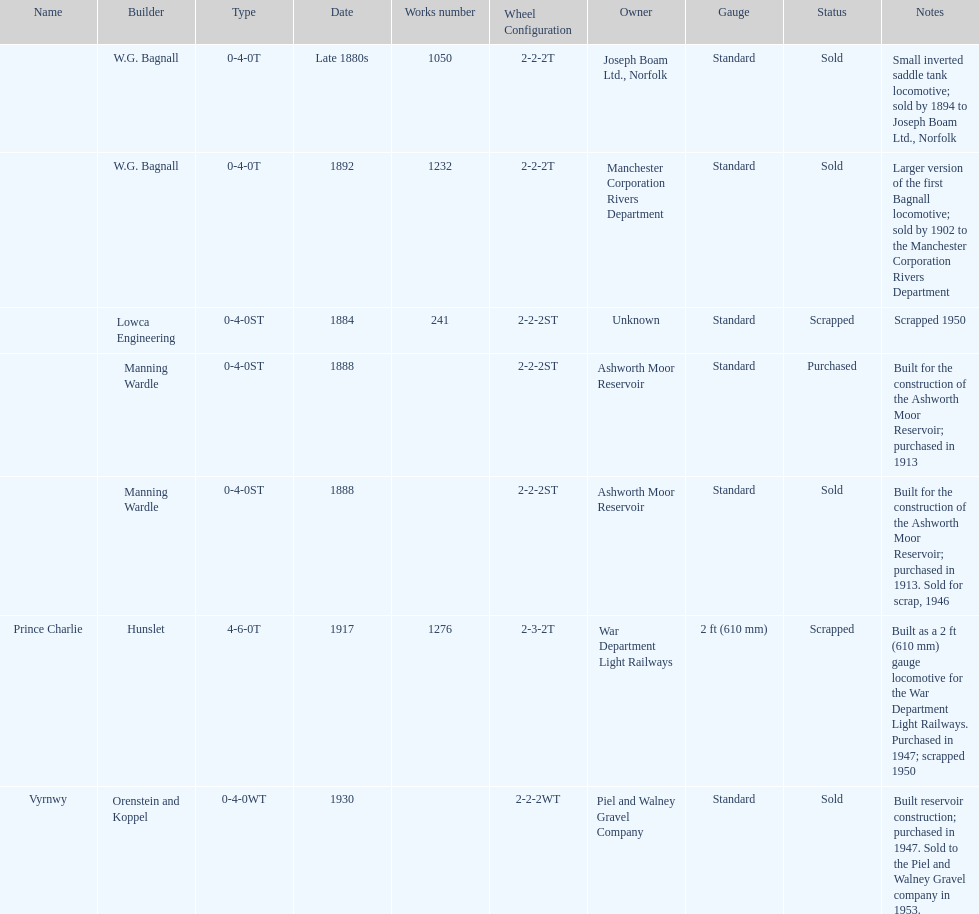Which locomotive builder built a locomotive after 1888 and built the locomotive as a 2ft gauge locomotive? Hunslet. 